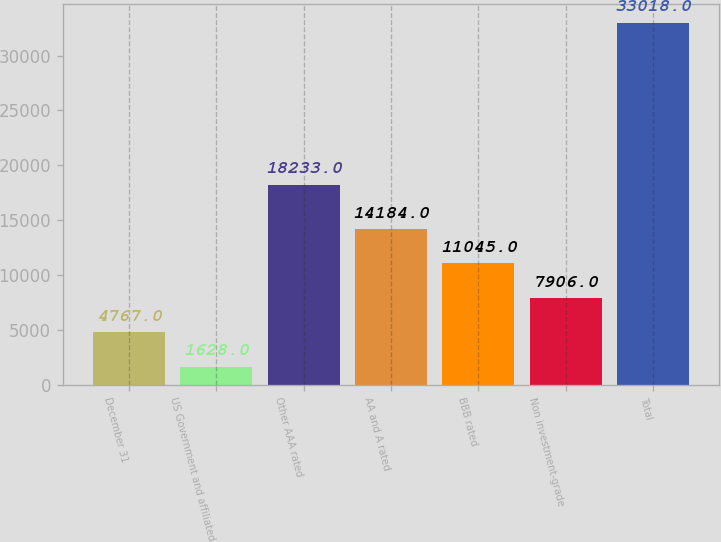Convert chart to OTSL. <chart><loc_0><loc_0><loc_500><loc_500><bar_chart><fcel>December 31<fcel>US Government and affiliated<fcel>Other AAA rated<fcel>AA and A rated<fcel>BBB rated<fcel>Non investment-grade<fcel>Total<nl><fcel>4767<fcel>1628<fcel>18233<fcel>14184<fcel>11045<fcel>7906<fcel>33018<nl></chart> 